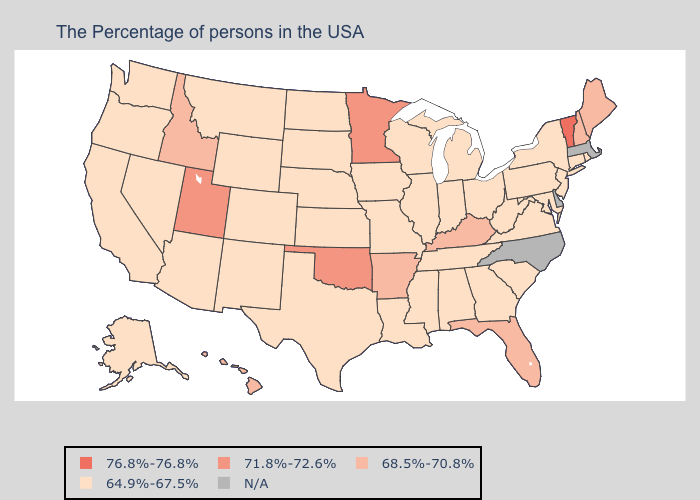Does the first symbol in the legend represent the smallest category?
Concise answer only. No. Does the first symbol in the legend represent the smallest category?
Answer briefly. No. What is the value of Maryland?
Answer briefly. 64.9%-67.5%. What is the highest value in the West ?
Be succinct. 71.8%-72.6%. Does Connecticut have the highest value in the Northeast?
Answer briefly. No. Does the first symbol in the legend represent the smallest category?
Keep it brief. No. What is the lowest value in the MidWest?
Short answer required. 64.9%-67.5%. Which states have the highest value in the USA?
Concise answer only. Vermont. What is the value of Nebraska?
Answer briefly. 64.9%-67.5%. Name the states that have a value in the range 64.9%-67.5%?
Give a very brief answer. Rhode Island, Connecticut, New York, New Jersey, Maryland, Pennsylvania, Virginia, South Carolina, West Virginia, Ohio, Georgia, Michigan, Indiana, Alabama, Tennessee, Wisconsin, Illinois, Mississippi, Louisiana, Missouri, Iowa, Kansas, Nebraska, Texas, South Dakota, North Dakota, Wyoming, Colorado, New Mexico, Montana, Arizona, Nevada, California, Washington, Oregon, Alaska. What is the value of Kansas?
Keep it brief. 64.9%-67.5%. Name the states that have a value in the range N/A?
Be succinct. Massachusetts, Delaware, North Carolina. 